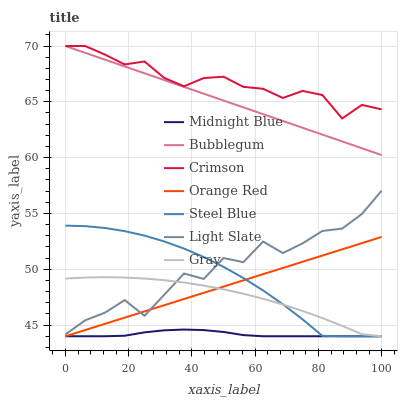Does Midnight Blue have the minimum area under the curve?
Answer yes or no. Yes. Does Crimson have the maximum area under the curve?
Answer yes or no. Yes. Does Light Slate have the minimum area under the curve?
Answer yes or no. No. Does Light Slate have the maximum area under the curve?
Answer yes or no. No. Is Orange Red the smoothest?
Answer yes or no. Yes. Is Light Slate the roughest?
Answer yes or no. Yes. Is Midnight Blue the smoothest?
Answer yes or no. No. Is Midnight Blue the roughest?
Answer yes or no. No. Does Light Slate have the lowest value?
Answer yes or no. No. Does Crimson have the highest value?
Answer yes or no. Yes. Does Light Slate have the highest value?
Answer yes or no. No. Is Midnight Blue less than Bubblegum?
Answer yes or no. Yes. Is Crimson greater than Light Slate?
Answer yes or no. Yes. Does Midnight Blue intersect Orange Red?
Answer yes or no. Yes. Is Midnight Blue less than Orange Red?
Answer yes or no. No. Is Midnight Blue greater than Orange Red?
Answer yes or no. No. Does Midnight Blue intersect Bubblegum?
Answer yes or no. No. 